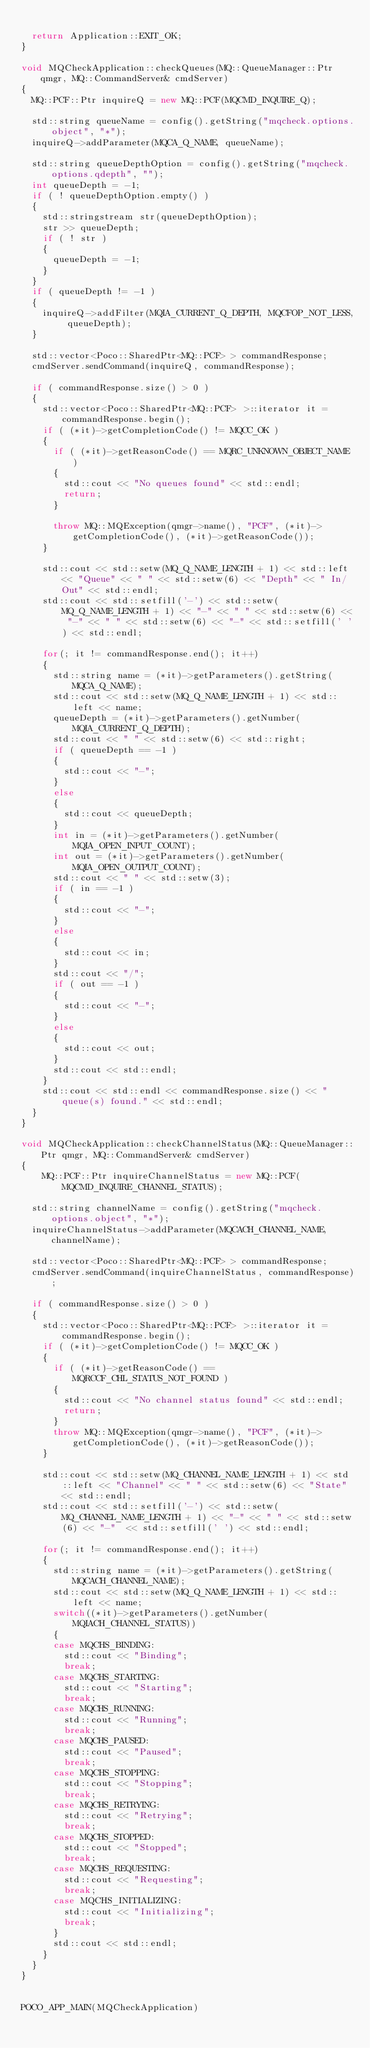<code> <loc_0><loc_0><loc_500><loc_500><_C++_>
  return Application::EXIT_OK;
}

void MQCheckApplication::checkQueues(MQ::QueueManager::Ptr qmgr, MQ::CommandServer& cmdServer)
{
  MQ::PCF::Ptr inquireQ = new MQ::PCF(MQCMD_INQUIRE_Q);

  std::string queueName = config().getString("mqcheck.options.object", "*");
  inquireQ->addParameter(MQCA_Q_NAME, queueName);

  std::string queueDepthOption = config().getString("mqcheck.options.qdepth", "");
  int queueDepth = -1;
  if ( ! queueDepthOption.empty() )
  {
    std::stringstream str(queueDepthOption);
    str >> queueDepth;
    if ( ! str )
    {
      queueDepth = -1;
    }
  }
  if ( queueDepth != -1 )
  {
    inquireQ->addFilter(MQIA_CURRENT_Q_DEPTH, MQCFOP_NOT_LESS, queueDepth);
  }

  std::vector<Poco::SharedPtr<MQ::PCF> > commandResponse;
  cmdServer.sendCommand(inquireQ, commandResponse);

  if ( commandResponse.size() > 0 )
  {
    std::vector<Poco::SharedPtr<MQ::PCF> >::iterator it = commandResponse.begin();
    if ( (*it)->getCompletionCode() != MQCC_OK )
    {
      if ( (*it)->getReasonCode() == MQRC_UNKNOWN_OBJECT_NAME )
      {
        std::cout << "No queues found" << std::endl;
        return;
      }

      throw MQ::MQException(qmgr->name(), "PCF", (*it)->getCompletionCode(), (*it)->getReasonCode());
    }

    std::cout << std::setw(MQ_Q_NAME_LENGTH + 1) << std::left << "Queue" << " " << std::setw(6) << "Depth" << " In/Out" << std::endl;
    std::cout << std::setfill('-') << std::setw(MQ_Q_NAME_LENGTH + 1) << "-" << " " << std::setw(6) << "-" << " " << std::setw(6) << "-" << std::setfill(' ') << std::endl;

    for(; it != commandResponse.end(); it++)
    {
      std::string name = (*it)->getParameters().getString(MQCA_Q_NAME);
      std::cout << std::setw(MQ_Q_NAME_LENGTH + 1) << std::left << name;
      queueDepth = (*it)->getParameters().getNumber(MQIA_CURRENT_Q_DEPTH);
      std::cout << " " << std::setw(6) << std::right;
      if ( queueDepth == -1 )
      {
        std::cout << "-";
      }
      else
      {
        std::cout << queueDepth;
      }
      int in = (*it)->getParameters().getNumber(MQIA_OPEN_INPUT_COUNT);
      int out = (*it)->getParameters().getNumber(MQIA_OPEN_OUTPUT_COUNT);
      std::cout << " " << std::setw(3);
      if ( in == -1 )
      {
        std::cout << "-";
      }
      else
      {
        std::cout << in;
      }
      std::cout << "/";
      if ( out == -1 )
      {
        std::cout << "-";
      }
      else
      {
        std::cout << out;
      }
      std::cout << std::endl;
    }
    std::cout << std::endl << commandResponse.size() << " queue(s) found." << std::endl;
  }
}

void MQCheckApplication::checkChannelStatus(MQ::QueueManager::Ptr qmgr, MQ::CommandServer& cmdServer)
{
	MQ::PCF::Ptr inquireChannelStatus = new MQ::PCF(MQCMD_INQUIRE_CHANNEL_STATUS);

  std::string channelName = config().getString("mqcheck.options.object", "*");
  inquireChannelStatus->addParameter(MQCACH_CHANNEL_NAME, channelName);

  std::vector<Poco::SharedPtr<MQ::PCF> > commandResponse;
  cmdServer.sendCommand(inquireChannelStatus, commandResponse);

  if ( commandResponse.size() > 0 )
  {
    std::vector<Poco::SharedPtr<MQ::PCF> >::iterator it = commandResponse.begin();
    if ( (*it)->getCompletionCode() != MQCC_OK )
    {
      if ( (*it)->getReasonCode() == MQRCCF_CHL_STATUS_NOT_FOUND )
      {
        std::cout << "No channel status found" << std::endl;
        return;
      }
      throw MQ::MQException(qmgr->name(), "PCF", (*it)->getCompletionCode(), (*it)->getReasonCode());
    }

    std::cout << std::setw(MQ_CHANNEL_NAME_LENGTH + 1) << std::left << "Channel" << " " << std::setw(6) << "State" << std::endl;
    std::cout << std::setfill('-') << std::setw(MQ_CHANNEL_NAME_LENGTH + 1) << "-" << " " << std::setw(6) << "-"  << std::setfill(' ') << std::endl;

    for(; it != commandResponse.end(); it++)
    {
      std::string name = (*it)->getParameters().getString(MQCACH_CHANNEL_NAME);
      std::cout << std::setw(MQ_Q_NAME_LENGTH + 1) << std::left << name;
      switch((*it)->getParameters().getNumber(MQIACH_CHANNEL_STATUS))
      {
      case MQCHS_BINDING:
        std::cout << "Binding";
        break;
      case MQCHS_STARTING:
        std::cout << "Starting";
        break;
      case MQCHS_RUNNING:
        std::cout << "Running";
        break;
      case MQCHS_PAUSED:
        std::cout << "Paused";
        break;
      case MQCHS_STOPPING:
        std::cout << "Stopping";
        break;
      case MQCHS_RETRYING:
        std::cout << "Retrying";
        break;
      case MQCHS_STOPPED:
        std::cout << "Stopped";
        break;
      case MQCHS_REQUESTING:
        std::cout << "Requesting";
        break;
      case MQCHS_INITIALIZING:
        std::cout << "Initializing";
        break;
      }
      std::cout << std::endl;
    }
  }
}


POCO_APP_MAIN(MQCheckApplication)
</code> 